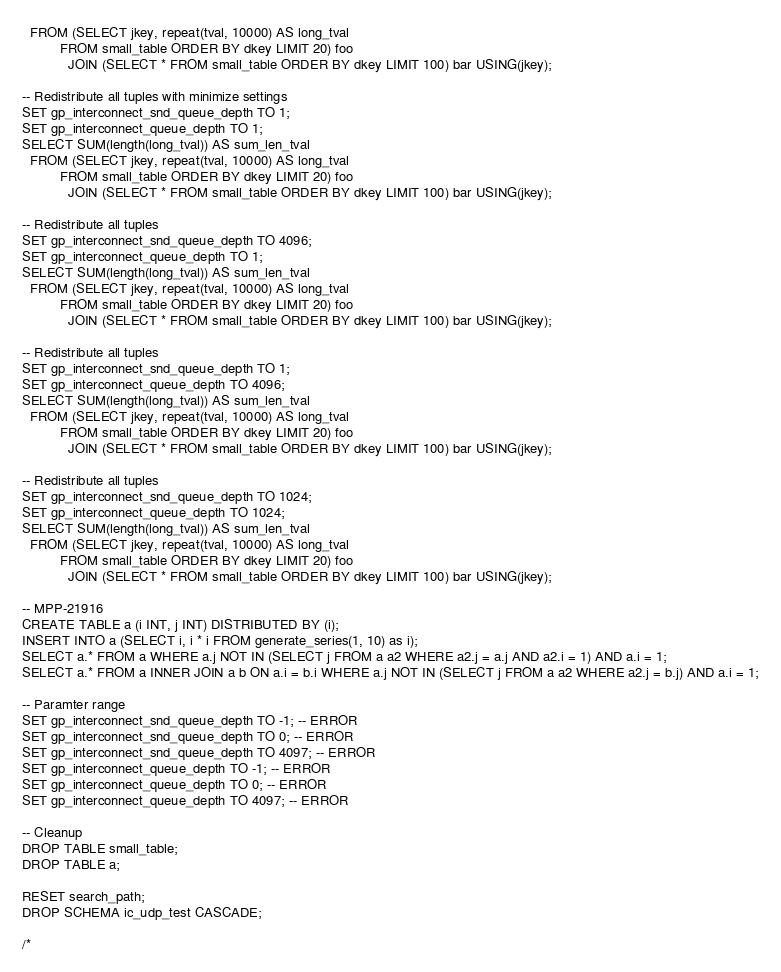Convert code to text. <code><loc_0><loc_0><loc_500><loc_500><_SQL_>  FROM (SELECT jkey, repeat(tval, 10000) AS long_tval
          FROM small_table ORDER BY dkey LIMIT 20) foo
            JOIN (SELECT * FROM small_table ORDER BY dkey LIMIT 100) bar USING(jkey);

-- Redistribute all tuples with minimize settings
SET gp_interconnect_snd_queue_depth TO 1;
SET gp_interconnect_queue_depth TO 1;
SELECT SUM(length(long_tval)) AS sum_len_tval
  FROM (SELECT jkey, repeat(tval, 10000) AS long_tval
          FROM small_table ORDER BY dkey LIMIT 20) foo
            JOIN (SELECT * FROM small_table ORDER BY dkey LIMIT 100) bar USING(jkey);

-- Redistribute all tuples
SET gp_interconnect_snd_queue_depth TO 4096;
SET gp_interconnect_queue_depth TO 1;
SELECT SUM(length(long_tval)) AS sum_len_tval
  FROM (SELECT jkey, repeat(tval, 10000) AS long_tval
          FROM small_table ORDER BY dkey LIMIT 20) foo
            JOIN (SELECT * FROM small_table ORDER BY dkey LIMIT 100) bar USING(jkey);

-- Redistribute all tuples
SET gp_interconnect_snd_queue_depth TO 1;
SET gp_interconnect_queue_depth TO 4096;
SELECT SUM(length(long_tval)) AS sum_len_tval
  FROM (SELECT jkey, repeat(tval, 10000) AS long_tval
          FROM small_table ORDER BY dkey LIMIT 20) foo
            JOIN (SELECT * FROM small_table ORDER BY dkey LIMIT 100) bar USING(jkey);

-- Redistribute all tuples
SET gp_interconnect_snd_queue_depth TO 1024;
SET gp_interconnect_queue_depth TO 1024;
SELECT SUM(length(long_tval)) AS sum_len_tval
  FROM (SELECT jkey, repeat(tval, 10000) AS long_tval
          FROM small_table ORDER BY dkey LIMIT 20) foo
            JOIN (SELECT * FROM small_table ORDER BY dkey LIMIT 100) bar USING(jkey);

-- MPP-21916
CREATE TABLE a (i INT, j INT) DISTRIBUTED BY (i);
INSERT INTO a (SELECT i, i * i FROM generate_series(1, 10) as i);
SELECT a.* FROM a WHERE a.j NOT IN (SELECT j FROM a a2 WHERE a2.j = a.j AND a2.i = 1) AND a.i = 1;
SELECT a.* FROM a INNER JOIN a b ON a.i = b.i WHERE a.j NOT IN (SELECT j FROM a a2 WHERE a2.j = b.j) AND a.i = 1;

-- Paramter range
SET gp_interconnect_snd_queue_depth TO -1; -- ERROR
SET gp_interconnect_snd_queue_depth TO 0; -- ERROR
SET gp_interconnect_snd_queue_depth TO 4097; -- ERROR
SET gp_interconnect_queue_depth TO -1; -- ERROR
SET gp_interconnect_queue_depth TO 0; -- ERROR
SET gp_interconnect_queue_depth TO 4097; -- ERROR

-- Cleanup
DROP TABLE small_table;
DROP TABLE a;

RESET search_path;
DROP SCHEMA ic_udp_test CASCADE;

/*</code> 